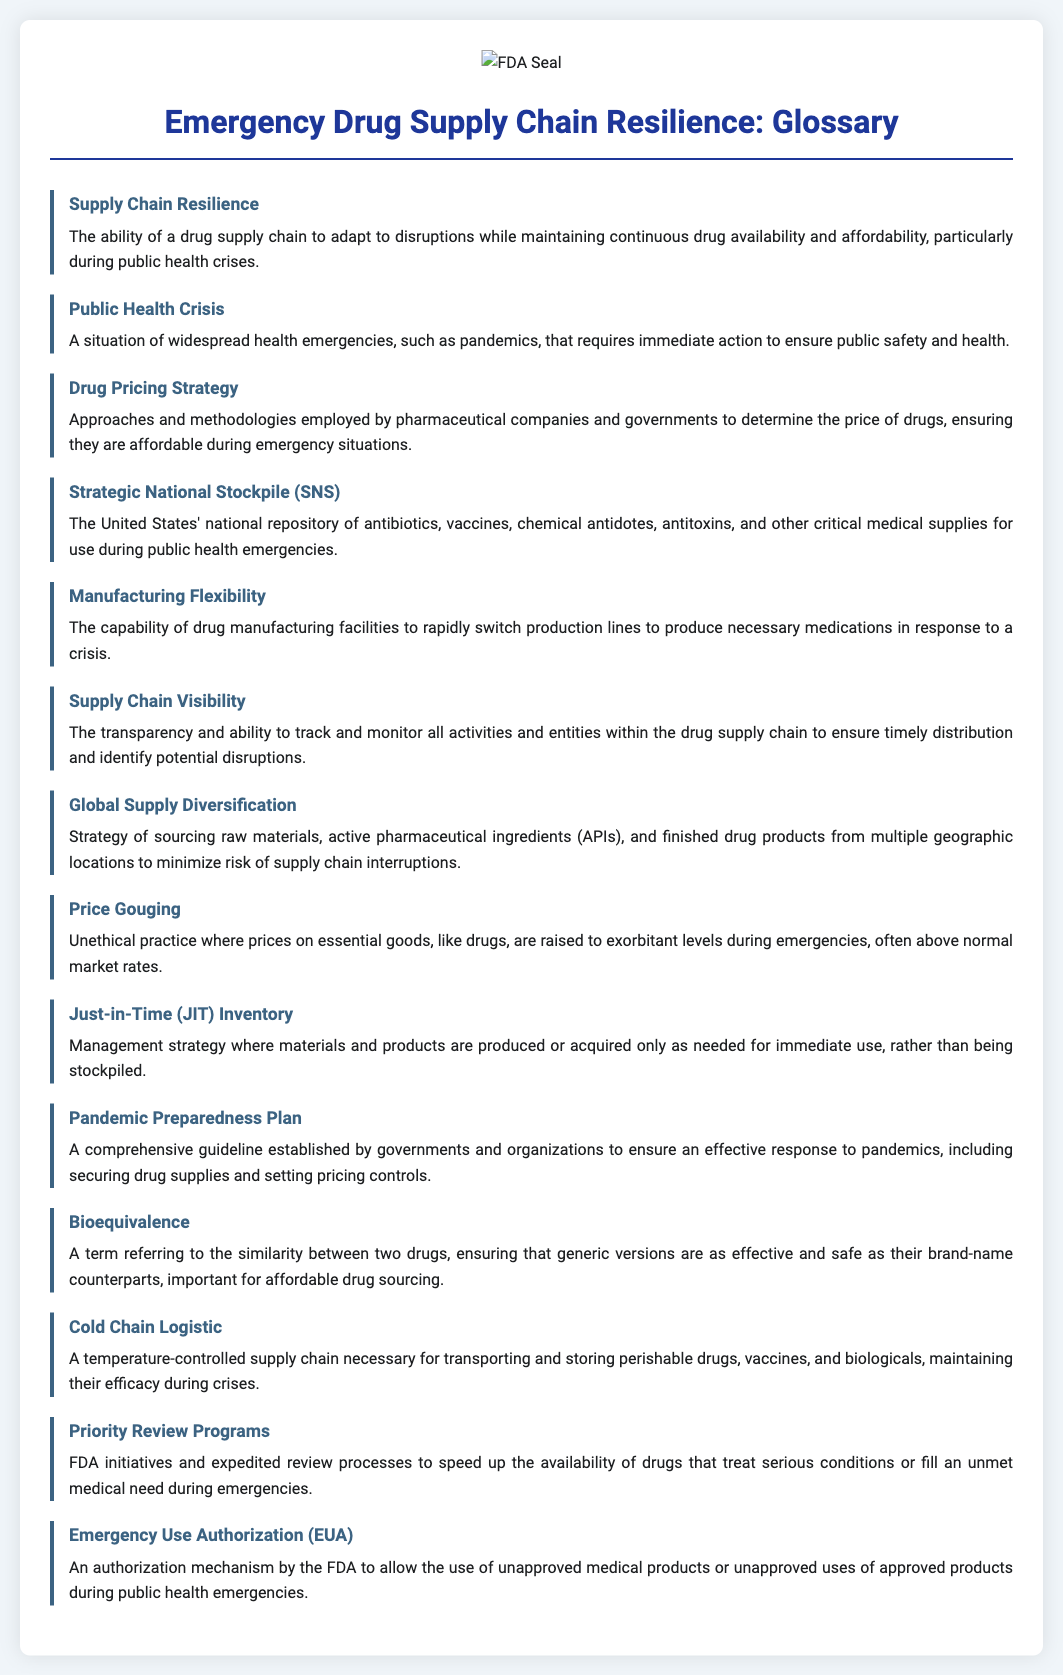what defines Supply Chain Resilience? The definition of Supply Chain Resilience is presented in the glossary, emphasizing its adaptability to disruptions while ensuring drug availability and affordability.
Answer: The ability of a drug supply chain to adapt to disruptions while maintaining continuous drug availability and affordability what is a Public Health Crisis? The document provides a clear definition of Public Health Crisis, describing it as a widespread health emergency requiring immediate action.
Answer: A situation of widespread health emergencies what does Drug Pricing Strategy refer to? The glossary defines Drug Pricing Strategy in the context of pharmaceutical pricing approaches during emergencies.
Answer: Approaches and methodologies employed by pharmaceutical companies and governments to determine the price of drugs what is the Strategic National Stockpile? The definition of the Strategic National Stockpile is included in the glossary, outlining its purpose during public health emergencies.
Answer: The United States' national repository of antibiotics, vaccines, chemical antidotes, antitoxins, and other critical medical supplies what does Global Supply Diversification aim to achieve? The document explains that Global Supply Diversification is a strategy to reduce risks within the drug supply chain.
Answer: Strategy of sourcing raw materials, active pharmaceutical ingredients (APIs), and finished drug products from multiple geographic locations how does Price Gouging impact drug affordability? The glossary describes Price Gouging as an unethical practice during emergencies that affects pricing.
Answer: Unethical practice where prices on essential goods are raised to exorbitant levels what is a characteristic of Just-in-Time Inventory? The document outlines the key principle of Just-in-Time Inventory in drug management.
Answer: Management strategy where materials and products are produced or acquired only as needed what is the role of Emergency Use Authorization? The glossary describes Emergency Use Authorization as a mechanism that allows the use of unapproved products during health emergencies.
Answer: An authorization mechanism by the FDA to allow the use of unapproved medical products 